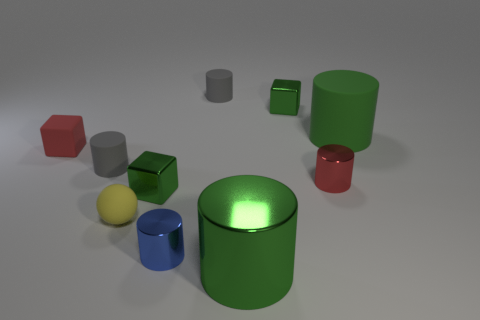Is the material of the small blue cylinder the same as the yellow object?
Provide a succinct answer. No. There is another large thing that is the same shape as the big metallic object; what is its material?
Ensure brevity in your answer.  Rubber. There is a red object that is right of the large green metal thing; is its shape the same as the small gray thing behind the large matte cylinder?
Offer a very short reply. Yes. Are there any large green cylinders that have the same material as the yellow thing?
Provide a short and direct response. Yes. Does the tiny green block that is behind the tiny red rubber cube have the same material as the yellow thing?
Your answer should be compact. No. Is the number of metallic things that are behind the blue object greater than the number of blue things behind the red shiny cylinder?
Your answer should be very brief. Yes. What color is the rubber sphere that is the same size as the rubber block?
Give a very brief answer. Yellow. Is there a tiny metallic object that has the same color as the rubber block?
Offer a very short reply. Yes. Does the tiny matte cylinder on the left side of the blue metallic cylinder have the same color as the tiny rubber thing behind the red rubber cube?
Make the answer very short. Yes. There is a cylinder that is on the right side of the red cylinder; what is it made of?
Your response must be concise. Rubber. 